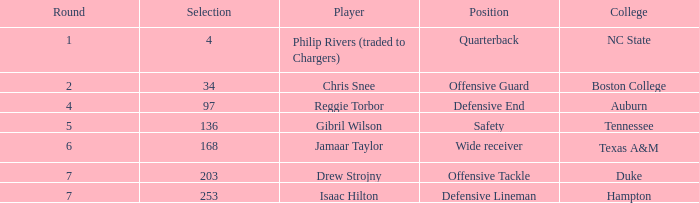Parse the table in full. {'header': ['Round', 'Selection', 'Player', 'Position', 'College'], 'rows': [['1', '4', 'Philip Rivers (traded to Chargers)', 'Quarterback', 'NC State'], ['2', '34', 'Chris Snee', 'Offensive Guard', 'Boston College'], ['4', '97', 'Reggie Torbor', 'Defensive End', 'Auburn'], ['5', '136', 'Gibril Wilson', 'Safety', 'Tennessee'], ['6', '168', 'Jamaar Taylor', 'Wide receiver', 'Texas A&M'], ['7', '203', 'Drew Strojny', 'Offensive Tackle', 'Duke'], ['7', '253', 'Isaac Hilton', 'Defensive Lineman', 'Hampton']]} Which option features a player of jamaar taylor, and a round greater than 6? None. 